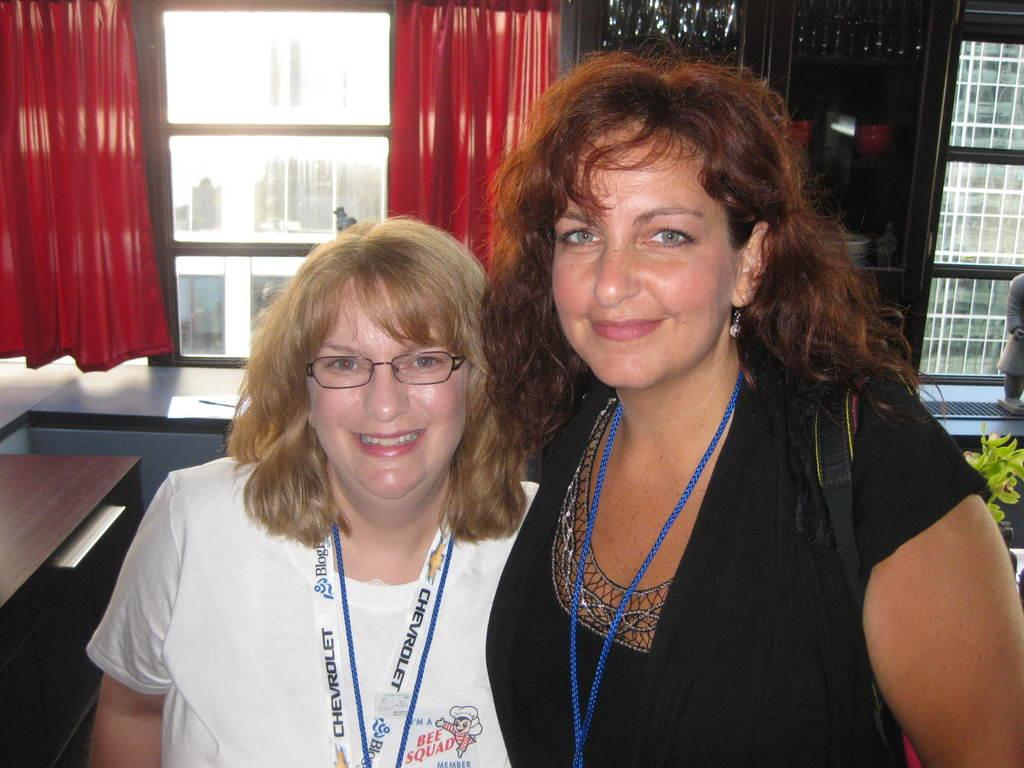How many people are in the image? There are two persons standing in the image. What is the facial expression of the persons? The persons are smiling. What type of vegetation is present in the image? There is a plant in the image. What can be seen inside the cupboard? There are objects in a cupboard. What architectural feature is visible in the image? There are windows in the image. What type of window treatment is present? There are curtains in the image. What type of structure is visible in the image? There is a building in the image. What other items can be seen in the image? There are other items in the image. How many dinosaurs are visible in the image? There are no dinosaurs present in the image. What direction are the chickens facing in the image? There are no chickens present in the image. 